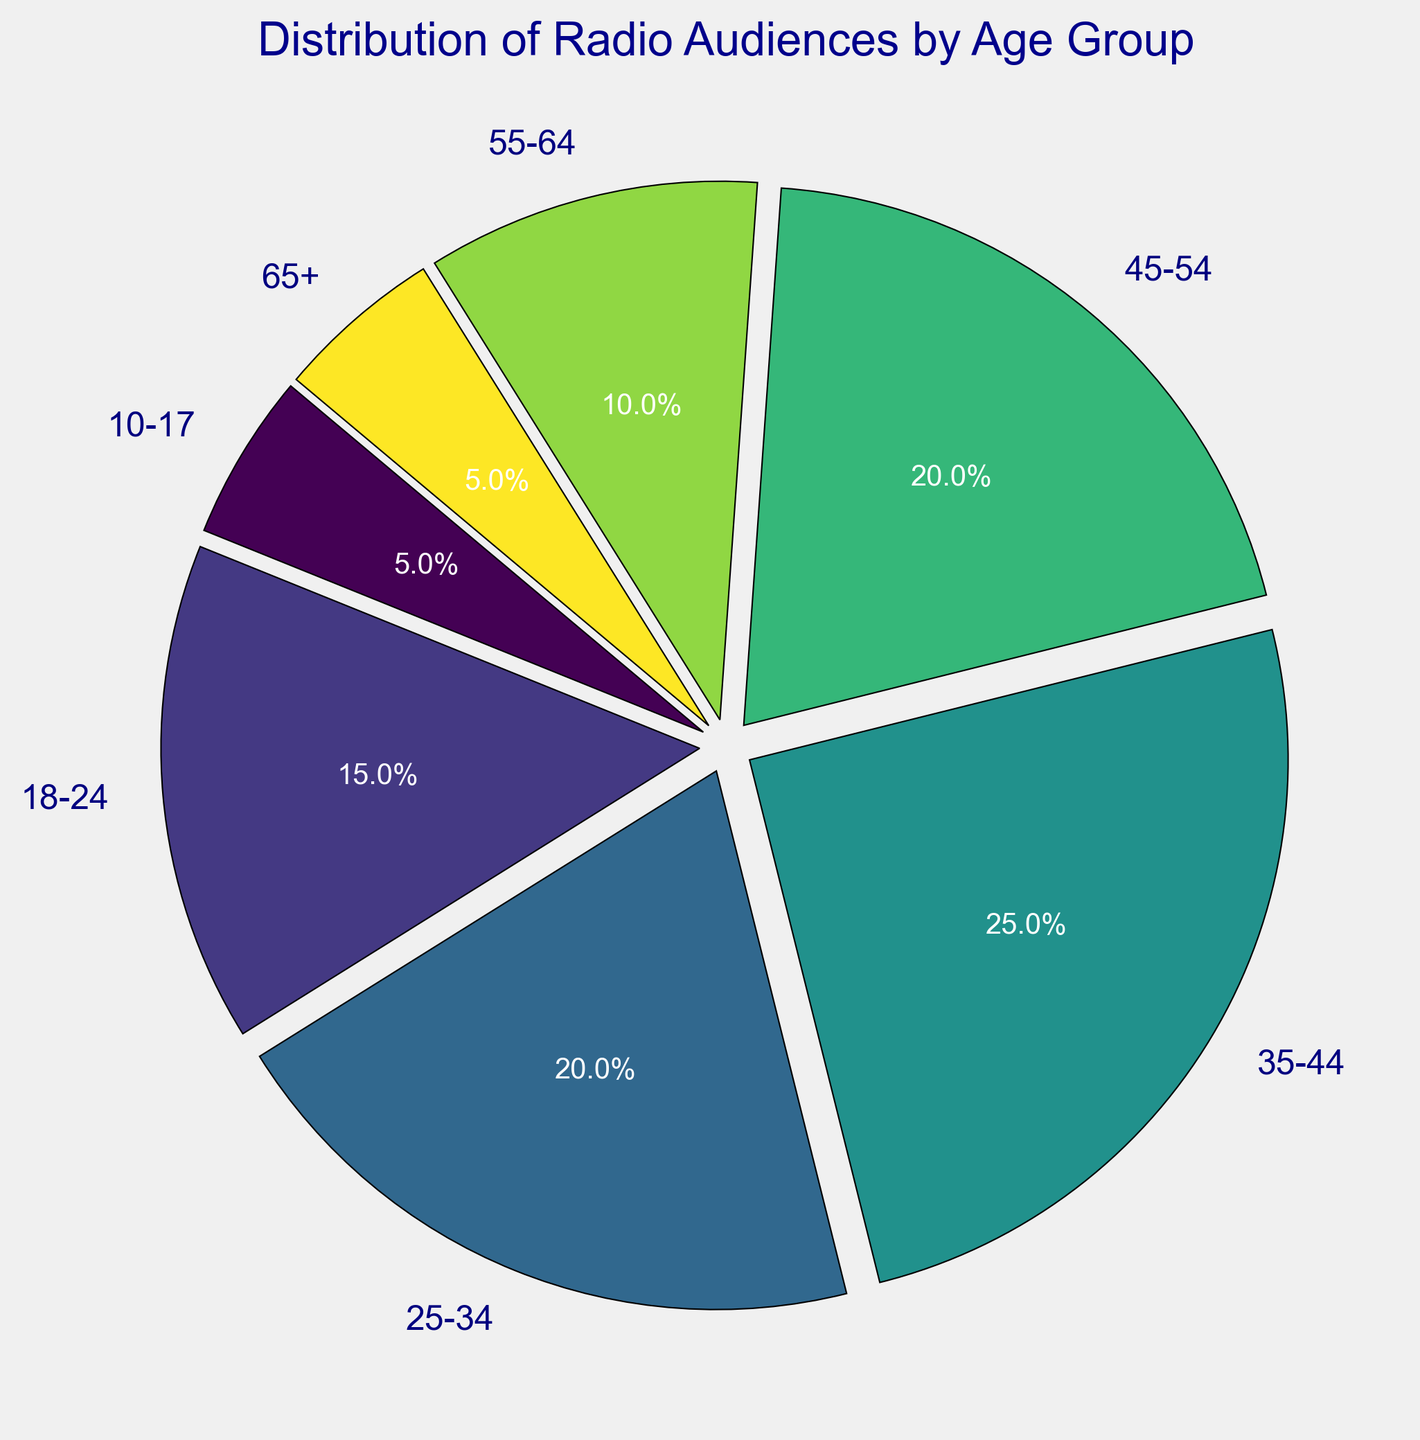Which age group has the highest radio audience percentage? By looking at the pie chart, the largest section of the pie corresponds to the 35-44 age group.
Answer: 35-44 Which age group has the smallest radio audience percentage? By observing the pie chart, the smallest segments are the 10-17 and 65+ age groups.
Answer: 10-17 and 65+ How many age groups have a percentage of 20% or more? By inspecting the chart, the age groups 25-34, 35-44, and 45-54 have percentages of 20%, 25%, and 20% respectively. This gives us three age groups.
Answer: 3 What is the combined percentage of radio audiences for the age groups 18-24 and 55-64? From the pie chart, the percentages for 18-24 and 55-64 are 15% and 10%. Adding these together gives 25%.
Answer: 25% Which age group has a radio audience percentage that is equal to the sum of the 10-17 and 65+ age groups? The percentages for 10-17 and 65+ are both 5%. Adding these together gives 10%, which matches the 55-64 age group.
Answer: 55-64 What is the difference in radio audience percentages between the age groups 35-44 and 25-34? By looking at the pie chart, the percentages for 35-44 and 25-34 are 25% and 20%. The difference is 5%.
Answer: 5% What is the average radio audience percentage for the age groups above 44 years old? Adding the percentages of 45-54, 55-64, and 65+ gives 20% + 10% + 5% = 35%. Dividing by 3 gives an average of 11.67%.
Answer: 11.67% Which age group represented on the chart is displayed with the darkest color? The pie chart uses colors from a viridis colormap. The darkest color corresponds to the 35-44 age group, which is also the largest segment.
Answer: 35-44 Which two age groups together make up the largest portion of the radio audience? By adding the percentages of the age groups, 35-44 and 25-34 have percentages of 25% and 20% respectively, which sum up to 45%, the highest combined percentage.
Answer: 35-44 and 25-34 